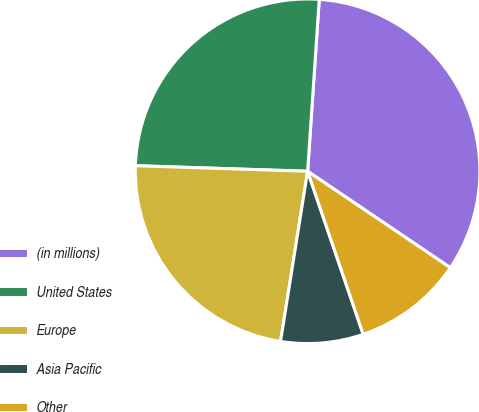<chart> <loc_0><loc_0><loc_500><loc_500><pie_chart><fcel>(in millions)<fcel>United States<fcel>Europe<fcel>Asia Pacific<fcel>Other<nl><fcel>33.38%<fcel>25.56%<fcel>23.0%<fcel>7.74%<fcel>10.31%<nl></chart> 